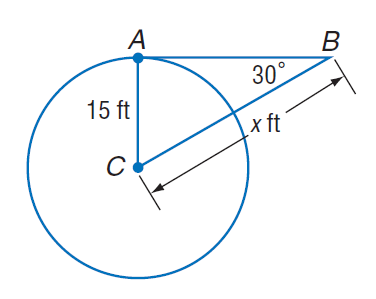Answer the mathemtical geometry problem and directly provide the correct option letter.
Question: Find x. Assume that segments that appear to be tangent are tangent.
Choices: A: 15 B: 20 C: 15 \sqrt { 3 } D: 30 D 